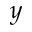<formula> <loc_0><loc_0><loc_500><loc_500>y</formula> 